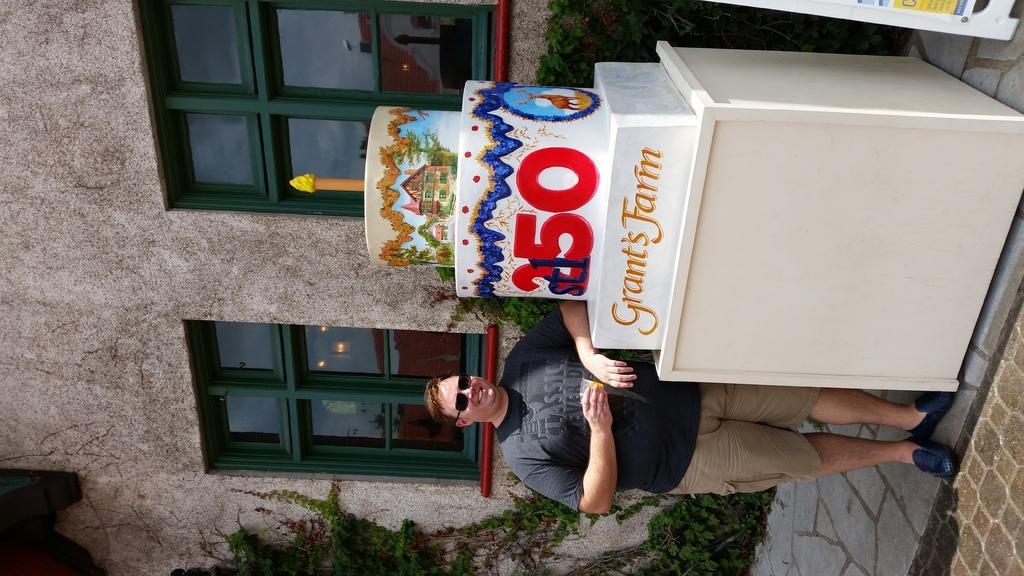Could you give a brief overview of what you see in this image? In this image, I can see a person standing and smiling. Beside the person, I can see an artificial cake with a candle on a table. Behind the person, I can see a building with windows and there are plants. 